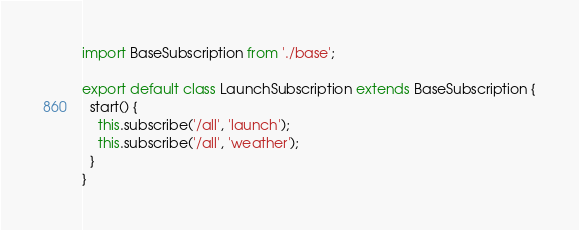<code> <loc_0><loc_0><loc_500><loc_500><_JavaScript_>import BaseSubscription from './base';

export default class LaunchSubscription extends BaseSubscription {
  start() {
    this.subscribe('/all', 'launch');
    this.subscribe('/all', 'weather');
  }
}

</code> 